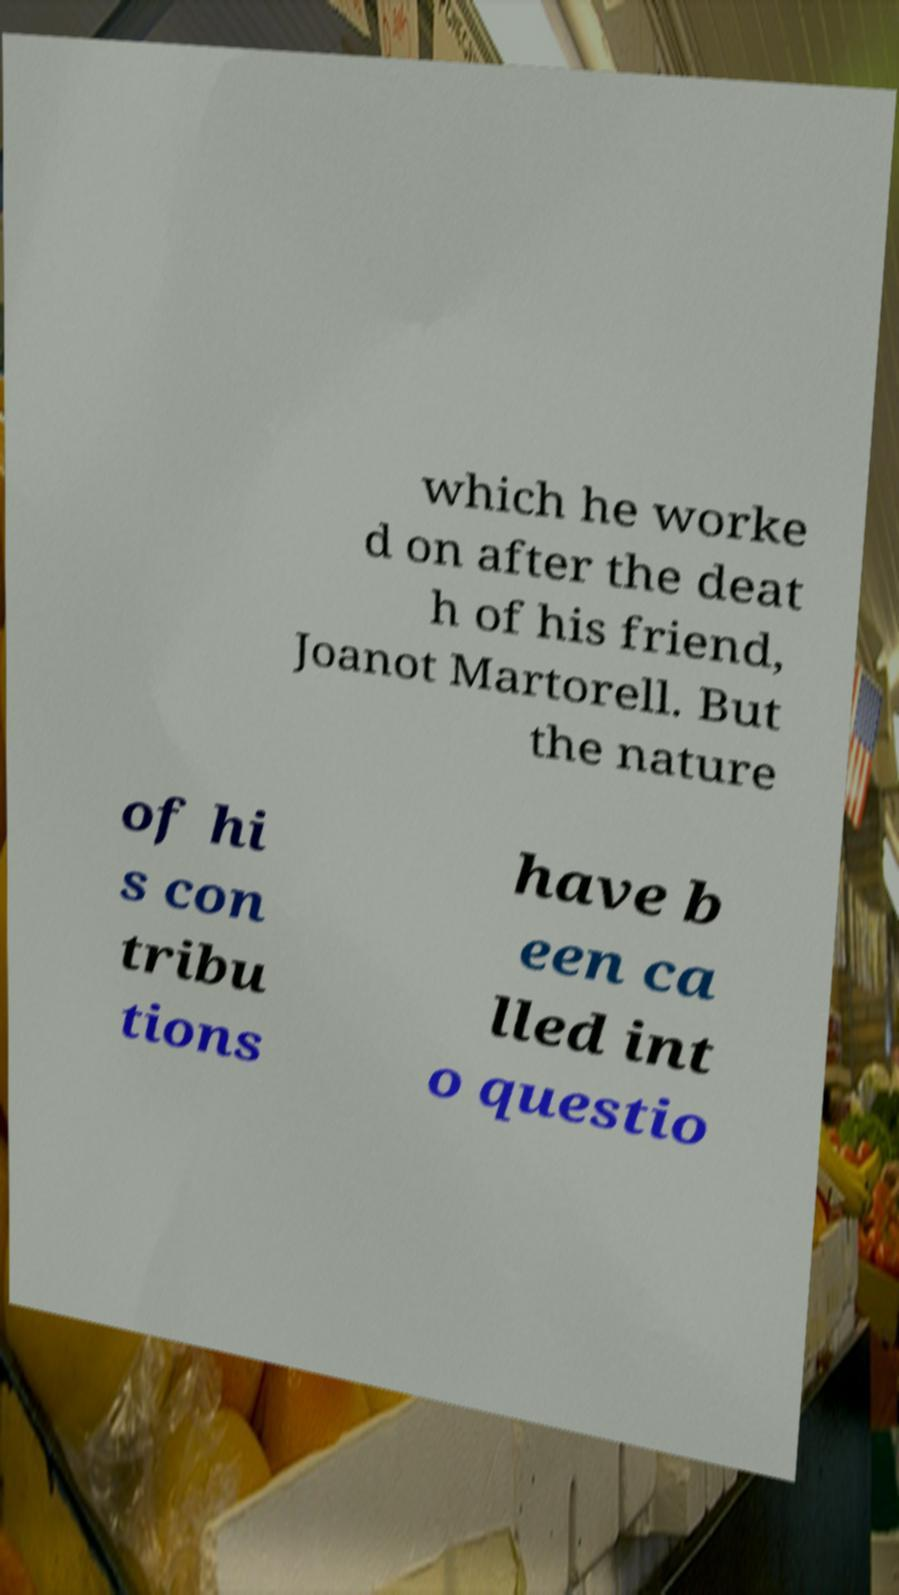Can you accurately transcribe the text from the provided image for me? which he worke d on after the deat h of his friend, Joanot Martorell. But the nature of hi s con tribu tions have b een ca lled int o questio 